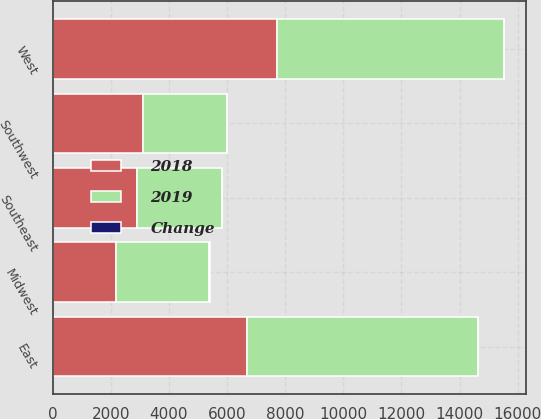<chart> <loc_0><loc_0><loc_500><loc_500><stacked_bar_chart><ecel><fcel>East<fcel>Midwest<fcel>Southeast<fcel>Southwest<fcel>West<nl><fcel>2019<fcel>7928<fcel>3193<fcel>2910<fcel>2910<fcel>7787<nl><fcel>2018<fcel>6697<fcel>2186<fcel>2910<fcel>3094<fcel>7724<nl><fcel>Change<fcel>18<fcel>46<fcel>8<fcel>6<fcel>1<nl></chart> 